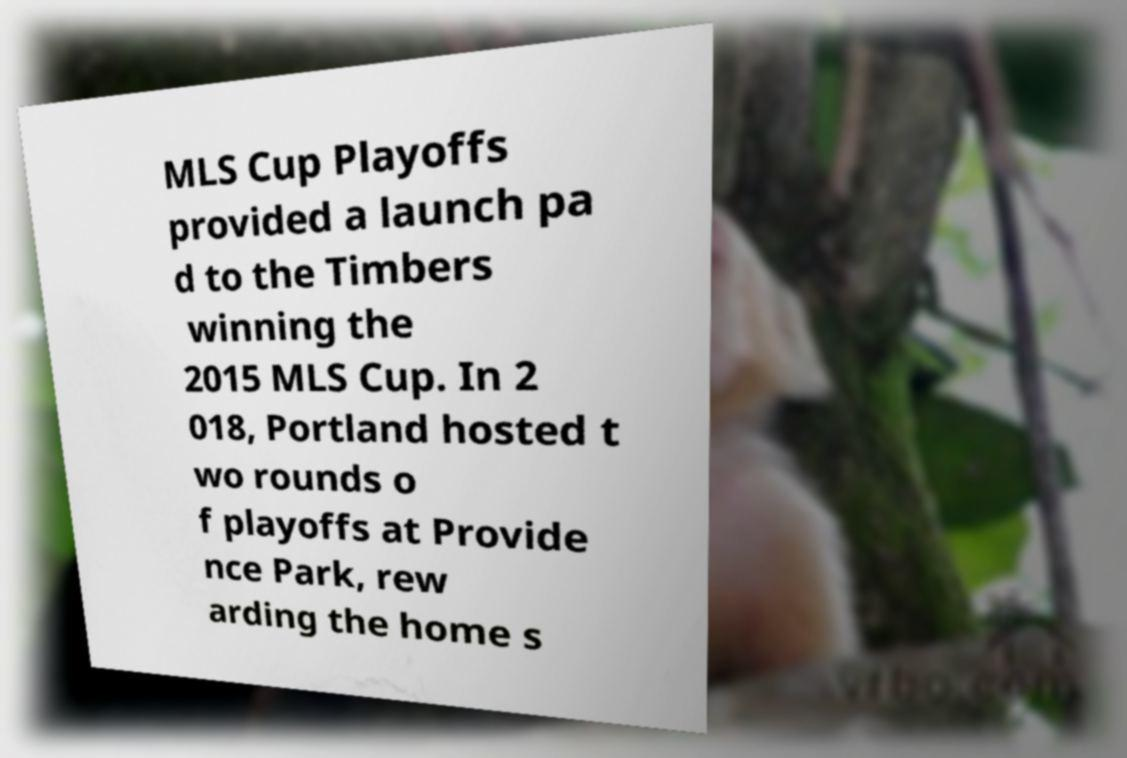Can you accurately transcribe the text from the provided image for me? MLS Cup Playoffs provided a launch pa d to the Timbers winning the 2015 MLS Cup. In 2 018, Portland hosted t wo rounds o f playoffs at Provide nce Park, rew arding the home s 